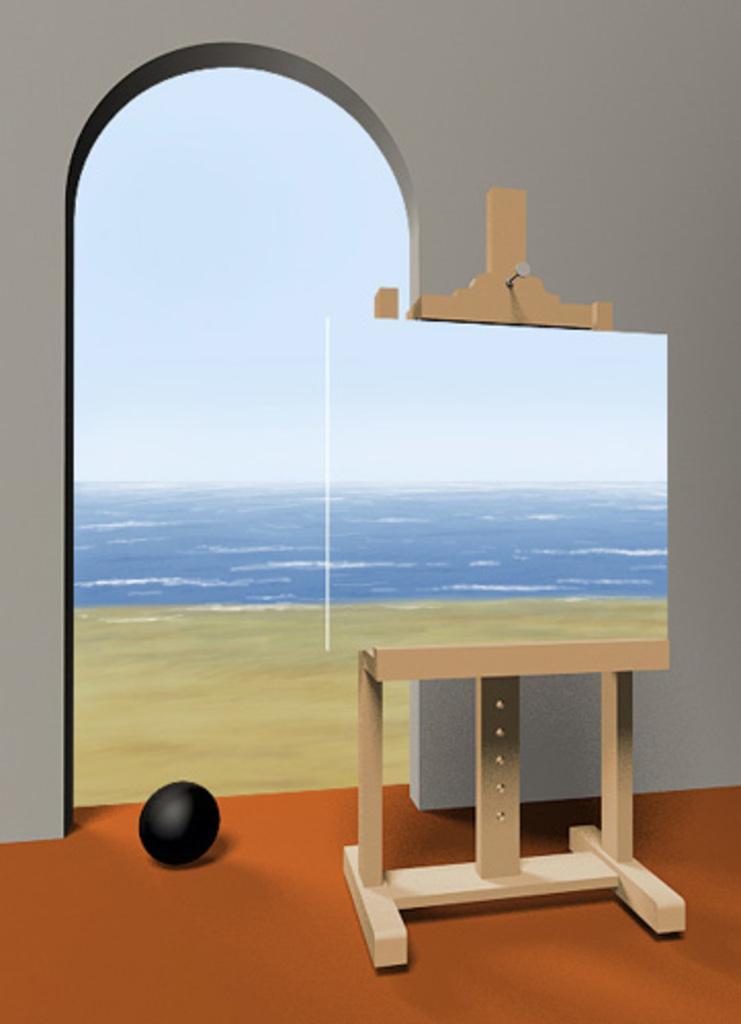Describe this image in one or two sentences. This image is an animated image. At the bottom of the image there is a floor. In the background there is a wall with a door and there is a sea and a ground. On the right side of the image there is a wooden stand with a board and a painting on it. 